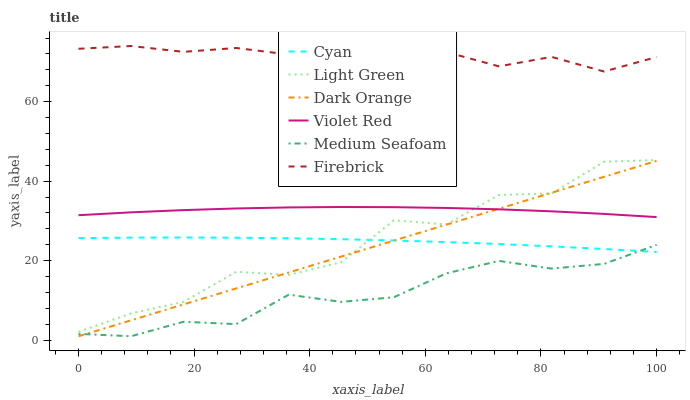Does Medium Seafoam have the minimum area under the curve?
Answer yes or no. Yes. Does Firebrick have the maximum area under the curve?
Answer yes or no. Yes. Does Violet Red have the minimum area under the curve?
Answer yes or no. No. Does Violet Red have the maximum area under the curve?
Answer yes or no. No. Is Dark Orange the smoothest?
Answer yes or no. Yes. Is Light Green the roughest?
Answer yes or no. Yes. Is Violet Red the smoothest?
Answer yes or no. No. Is Violet Red the roughest?
Answer yes or no. No. Does Dark Orange have the lowest value?
Answer yes or no. Yes. Does Violet Red have the lowest value?
Answer yes or no. No. Does Firebrick have the highest value?
Answer yes or no. Yes. Does Violet Red have the highest value?
Answer yes or no. No. Is Cyan less than Violet Red?
Answer yes or no. Yes. Is Firebrick greater than Medium Seafoam?
Answer yes or no. Yes. Does Light Green intersect Dark Orange?
Answer yes or no. Yes. Is Light Green less than Dark Orange?
Answer yes or no. No. Is Light Green greater than Dark Orange?
Answer yes or no. No. Does Cyan intersect Violet Red?
Answer yes or no. No. 